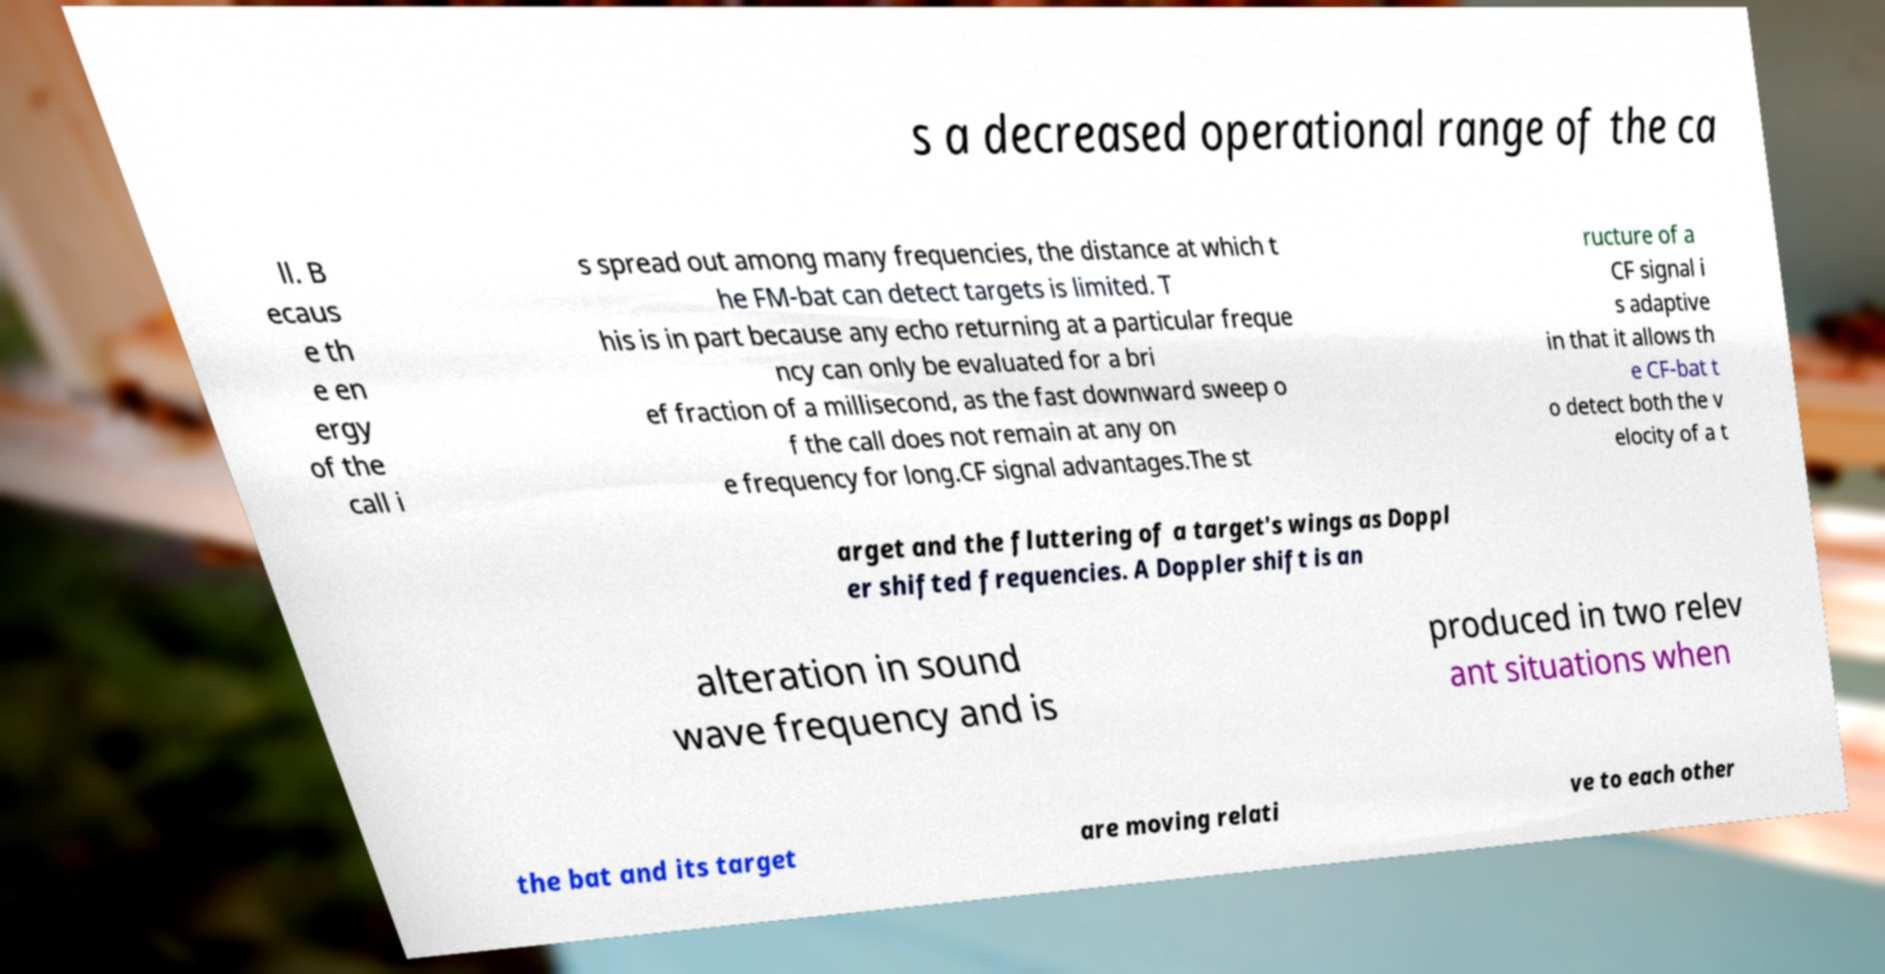There's text embedded in this image that I need extracted. Can you transcribe it verbatim? s a decreased operational range of the ca ll. B ecaus e th e en ergy of the call i s spread out among many frequencies, the distance at which t he FM-bat can detect targets is limited. T his is in part because any echo returning at a particular freque ncy can only be evaluated for a bri ef fraction of a millisecond, as the fast downward sweep o f the call does not remain at any on e frequency for long.CF signal advantages.The st ructure of a CF signal i s adaptive in that it allows th e CF-bat t o detect both the v elocity of a t arget and the fluttering of a target's wings as Doppl er shifted frequencies. A Doppler shift is an alteration in sound wave frequency and is produced in two relev ant situations when the bat and its target are moving relati ve to each other 